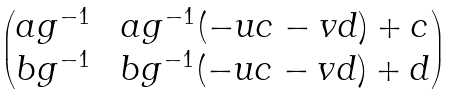<formula> <loc_0><loc_0><loc_500><loc_500>\begin{pmatrix} a g ^ { - 1 } \ & a g ^ { - 1 } ( - u c - v d ) + c \\ b g ^ { - 1 } \ & b g ^ { - 1 } ( - u c - v d ) + d \end{pmatrix}</formula> 